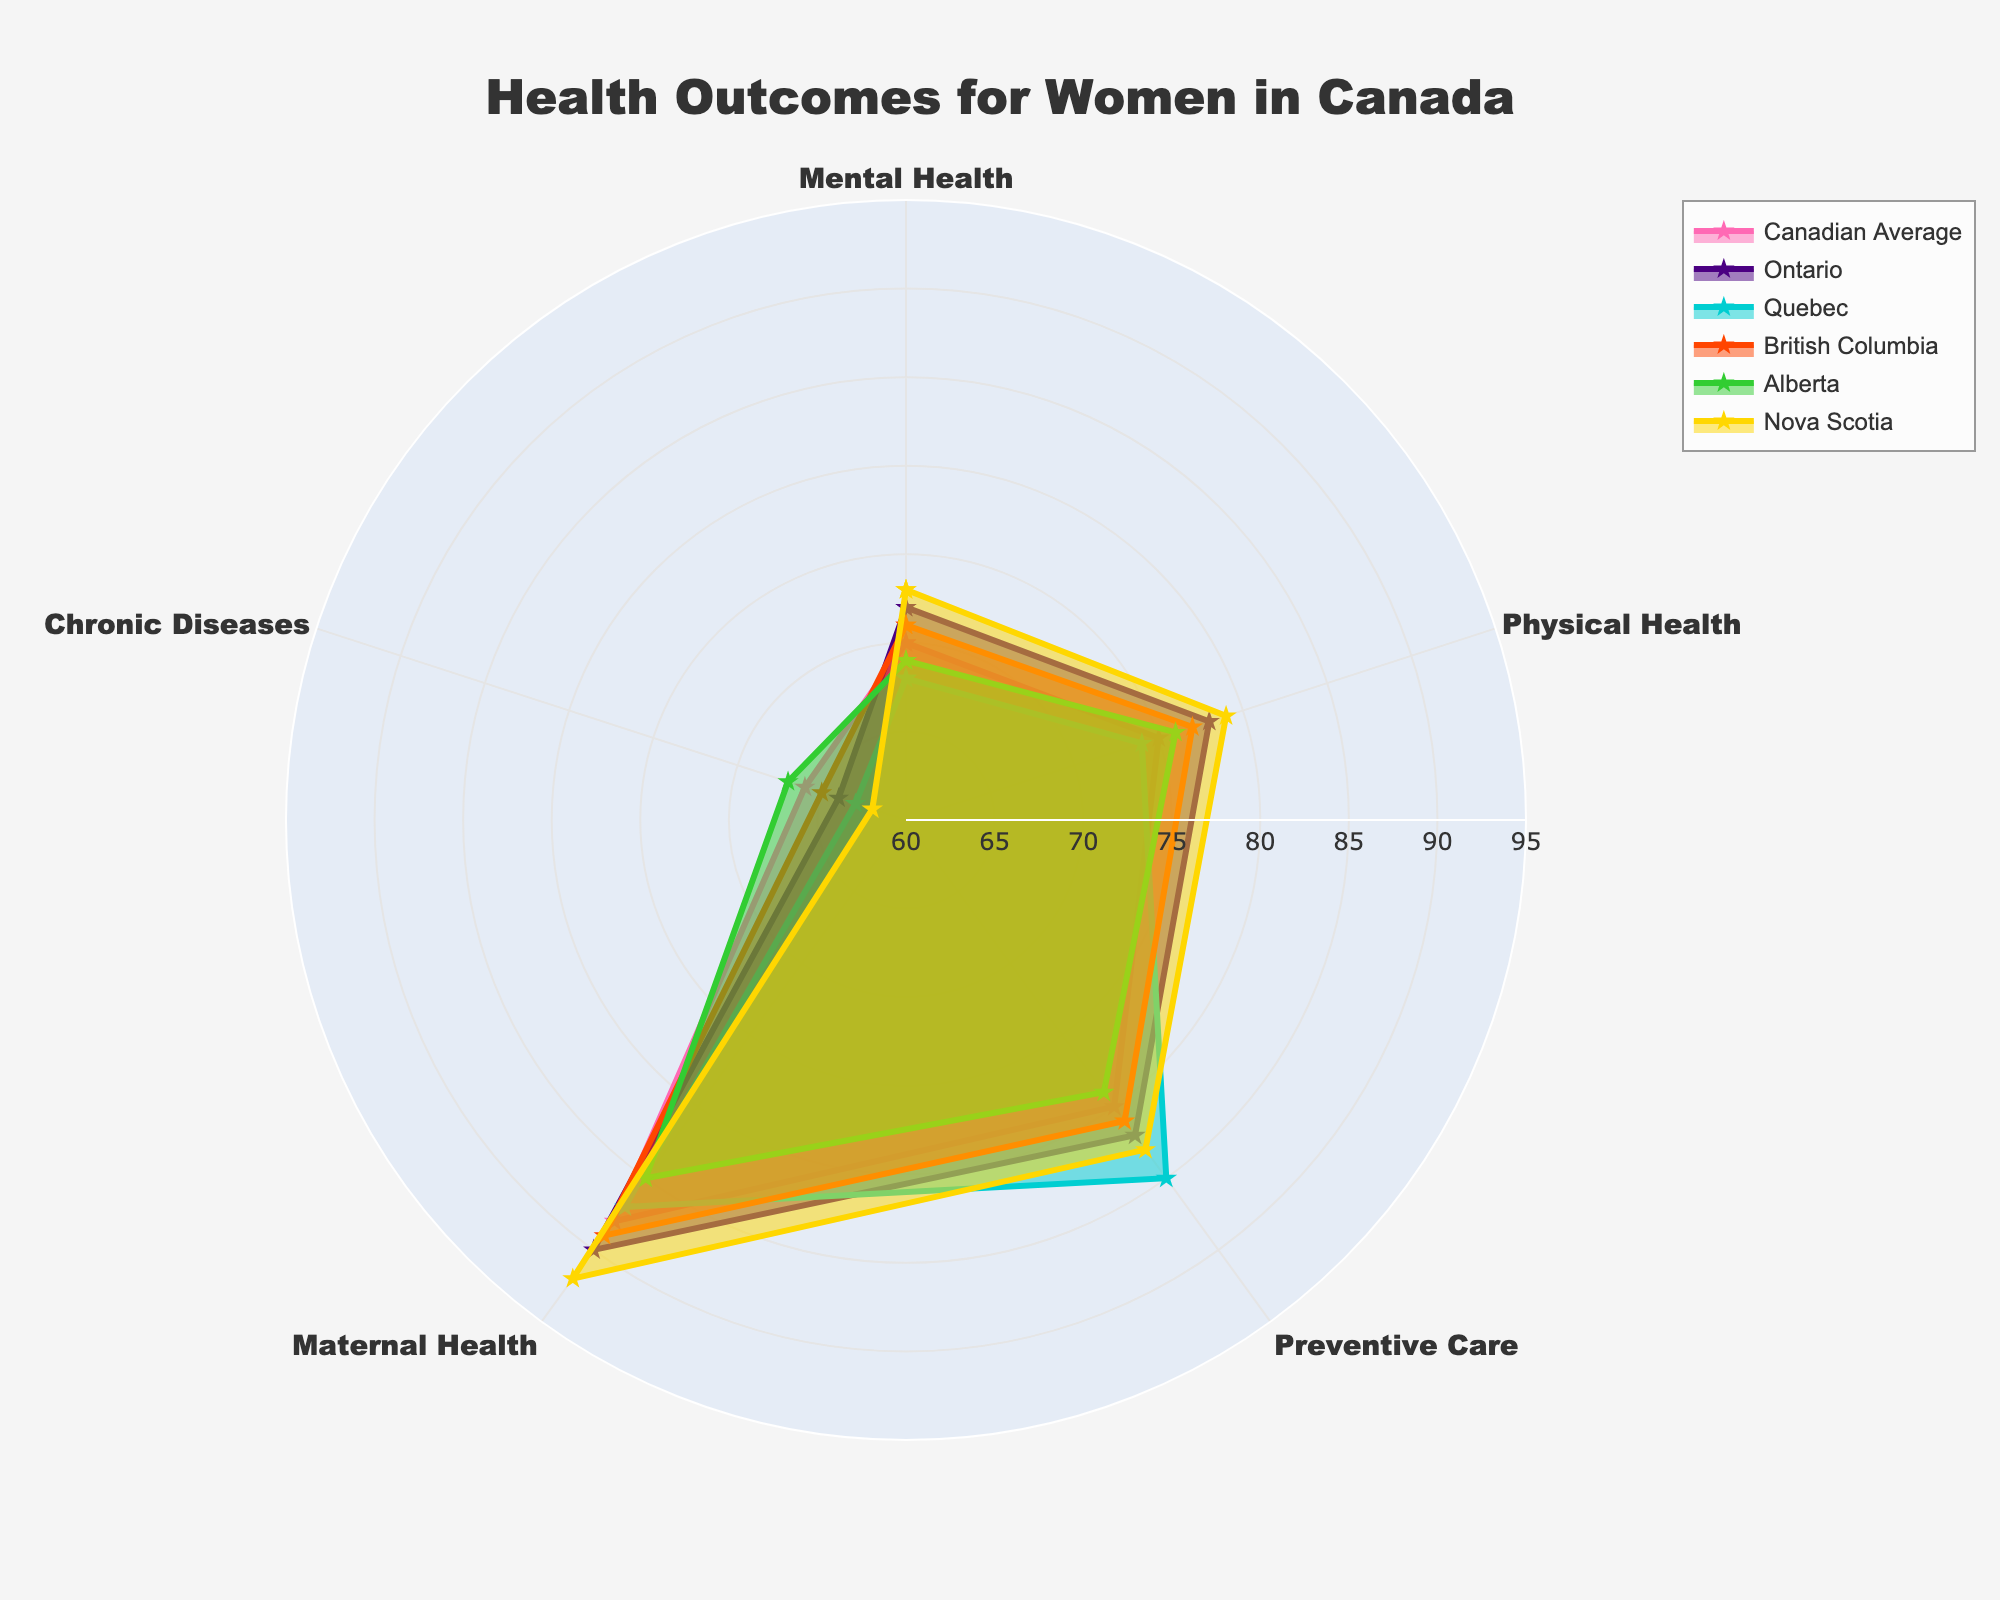Which health outcome category has the highest value for Nova Scotia? By observing Nova Scotia's data line on the radar chart, look for the longest or most outward-extending point. The category with the highest value is ‘Maternal Health’ at 92.
Answer: Maternal Health How does Quebec's Preventive Care compare to the Canadian average? Find the Preventive Care value for both Quebec (85) and the Canadian average (80) from the radar chart. Quebec's value is higher than the Canadian average.
Answer: Higher Which region has the lowest score in Chronic Diseases? Analyze the values for Chronic Diseases from each region shown on the radar chart. Nova Scotia has the lowest score at 62.
Answer: Nova Scotia What is the average value of Preventive Care across all regions? The Preventive Care values for all regions are: 80 (Canada), 82 (Ontario), 85 (Quebec), 81 (British Columbia), 79 (Alberta), and 83 (Nova Scotia). Sum these values and divide by the number of regions (6). (80+82+85+81+79+83)/6 = 81.67
Answer: 81.67 Which region has the most balanced health outcomes categories (the least spread out in values)? The region with the categories that are closest in values will appear most circular and least spiky in the radar chart. Ontario's data points are more uniform and rounded compared to others, indicating more balanced values.
Answer: Ontario Is Ontario's Mental Health value above or below the Canadian average? Compare Ontario's Mental Health value (72) to the Canadian average (70) from the radar chart. Ontario's value is above the Canadian average.
Answer: Above How many health outcome categories does Alberta have below the Canadian average? Compare Alberta’s values in each category to the Canadian average. Alberta has lower values in Mental Health (69 < 70) and Physical Health (76 < 75).
Answer: 2 Which category shows the greatest disparity between the highest and lowest regional values? Calculate the range (high-low) for each category. Maternal Health has the highest range: (92 - 85) = 7. Other categories have lesser disparities.
Answer: Maternal Health Does British Columbia have a value lower than 70 in any category? Examine British Columbia's values in the radar chart. The lowest value for British Columbia is Chronic Diseases at 65, which is below 70.
Answer: Yes What is the sum of the highest values in all categories from any region? Identify the highest value in each category across all regions and sum them. Maternal Health (Nova Scotia: 92), Preventive Care (Quebec: 85), Mental Health (Ontario: 72), Physical Health (Ontario: 78), Chronic Diseases (Alberta: 67). 92 + 85 + 72 + 78 + 67 = 394
Answer: 394 